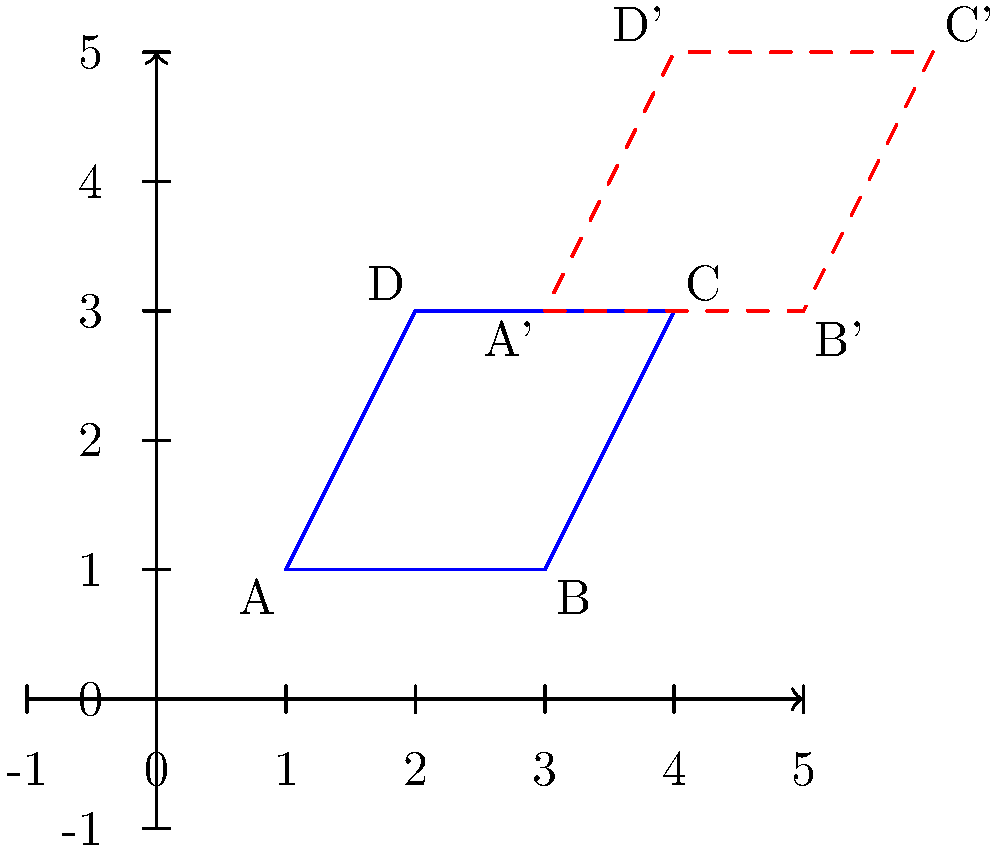As a single parent, you've mapped out your daily routine on a coordinate plane, where each point represents a different activity (e.g., school drop-off, work, grocery shopping, picking up kids). The blue shape ABCD represents your current routine. You're considering adjusting your schedule to accommodate a new after-school activity for your children. This adjustment can be represented by translating the entire shape 2 units right and 2 units up. What are the coordinates of point C after this translation? Let's approach this step-by-step:

1. First, we need to identify the original coordinates of point C.
   From the graph, we can see that C is at (4,3).

2. The translation is described as 2 units right and 2 units up.
   In coordinate geometry, this is represented as a translation of (2,2).

3. To translate a point, we add the translation vector to the original coordinates:
   
   New x-coordinate = Original x-coordinate + x-translation
   New y-coordinate = Original y-coordinate + y-translation

4. For point C:
   New x-coordinate = 4 + 2 = 6
   New y-coordinate = 3 + 2 = 5

5. Therefore, after translation, point C moves to (6,5).

This new point is labeled as C' on the graph, represented by the corresponding corner of the red dashed shape.
Answer: (6,5) 